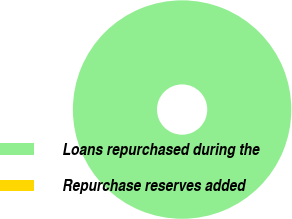Convert chart. <chart><loc_0><loc_0><loc_500><loc_500><pie_chart><fcel>Loans repurchased during the<fcel>Repurchase reserves added<nl><fcel>100.0%<fcel>0.0%<nl></chart> 